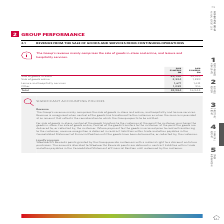According to Woolworths Limited's financial document, What is The Group's revenue mainly made up of? The Group’s revenue mainly comprises the sale of goods in-store and online, and hospitality and leisure services.. The document states: "The Group’s revenue mainly comprises the sale of goods in-store and online, and hospitality and leisure services. Revenue is recognised when control o..." Also, What is the sale of goods in-store in 2019? According to the financial document, 54,720 (in millions). The relevant text states: "Sale of goods in-store 54,720 52,533 Sale of goods online 2,534 1,883 Leisure and hospitality services 1,671 1,612 Other 1,059 91..." Also, What can customers do with the Woolworths Rewards points earned in the Loyalty program? Woolworths Rewards points granted by the Group provide customers with a material right to a discount on future purchases.. The document states: "Loyalty program Woolworths Rewards points granted by the Group provide customers with a material right to a discount on future purchases. The amounts ..." Also, can you calculate: What is the average sale of goods in-store for both 2018 and 2019? To answer this question, I need to perform calculations using the financial data. The calculation is: (54,720 + 52,533)/2 , which equals 53626.5 (in millions). This is based on the information: "Sale of goods in-store 54,720 52,533 Sale of goods online 2,534 1,883 Leisure and hospitality services 1,671 1,612 Other 1,059 916 Total Sale of goods in-store 54,720 52,533 Sale of goods online 2,534..." The key data points involved are: 52,533, 54,720. Also, can you calculate: What is the difference in value for sale of goods online between 2019 and 2018? Based on the calculation: 2,534 - 1,883 , the result is 651 (in millions). This is based on the information: "goods in-store 54,720 52,533 Sale of goods online 2,534 1,883 Leisure and hospitality services 1,671 1,612 Other 1,059 916 Total 59,984 56,944 in-store 54,720 52,533 Sale of goods online 2,534 1,883 L..." The key data points involved are: 1,883, 2,534. Also, can you calculate: What proportion does leisure and hospitality services constitute in the total revenue in 2019? Based on the calculation: 1,671/59,984 , the result is 2.79 (percentage). This is based on the information: "tality services 1,671 1,612 Other 1,059 916 Total 59,984 56,944 line 2,534 1,883 Leisure and hospitality services 1,671 1,612 Other 1,059 916 Total 59,984 56,944..." The key data points involved are: 1,671, 59,984. 